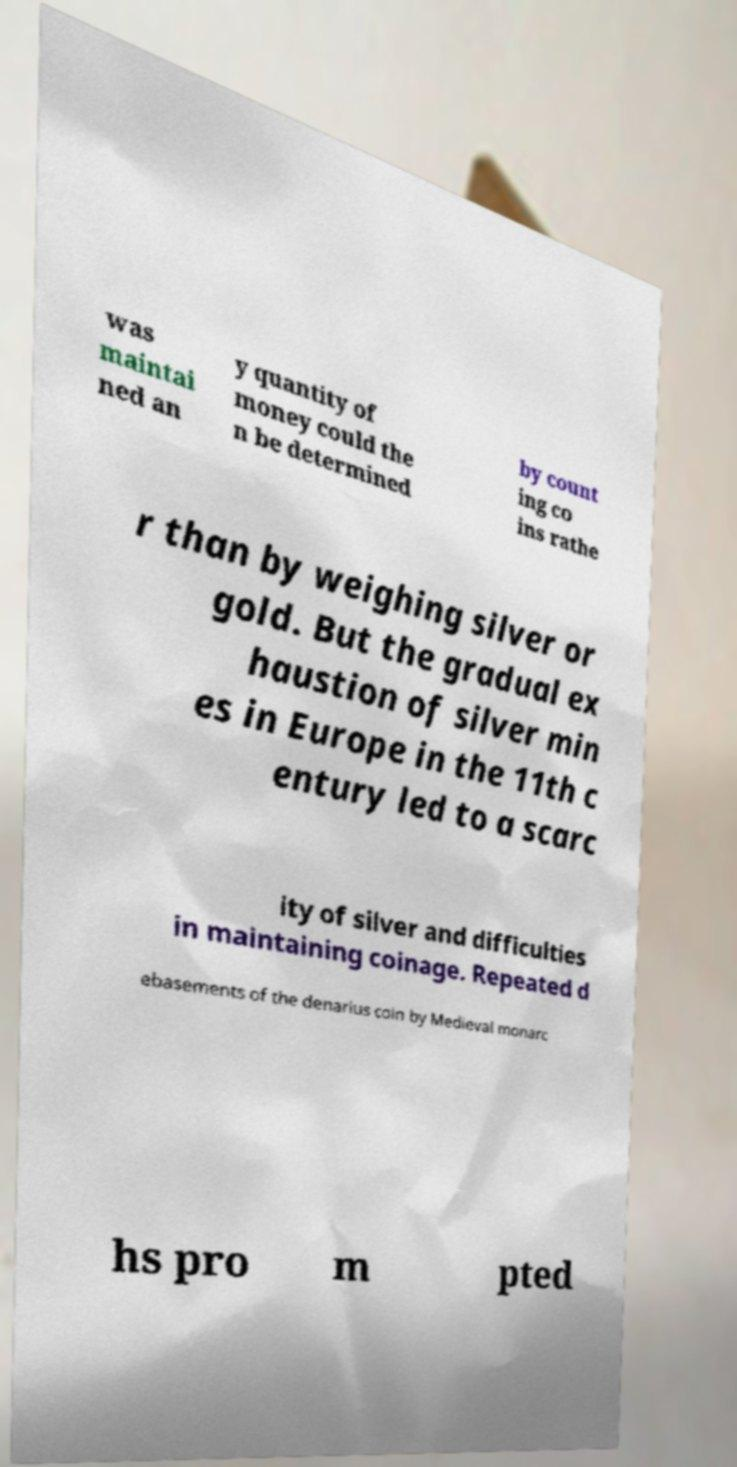There's text embedded in this image that I need extracted. Can you transcribe it verbatim? was maintai ned an y quantity of money could the n be determined by count ing co ins rathe r than by weighing silver or gold. But the gradual ex haustion of silver min es in Europe in the 11th c entury led to a scarc ity of silver and difficulties in maintaining coinage. Repeated d ebasements of the denarius coin by Medieval monarc hs pro m pted 